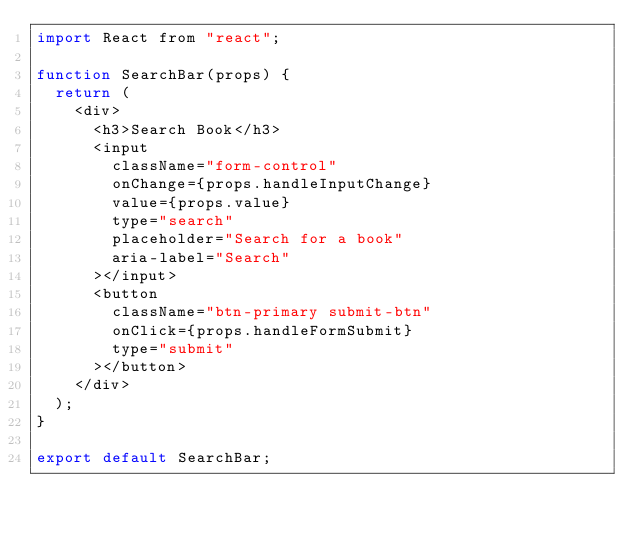<code> <loc_0><loc_0><loc_500><loc_500><_JavaScript_>import React from "react";

function SearchBar(props) {
  return (
    <div>
      <h3>Search Book</h3>
      <input
        className="form-control"
        onChange={props.handleInputChange}
        value={props.value}
        type="search"
        placeholder="Search for a book"
        aria-label="Search"
      ></input>
      <button
        className="btn-primary submit-btn"
        onClick={props.handleFormSubmit}
        type="submit"
      ></button>
    </div>
  );
}

export default SearchBar;
</code> 